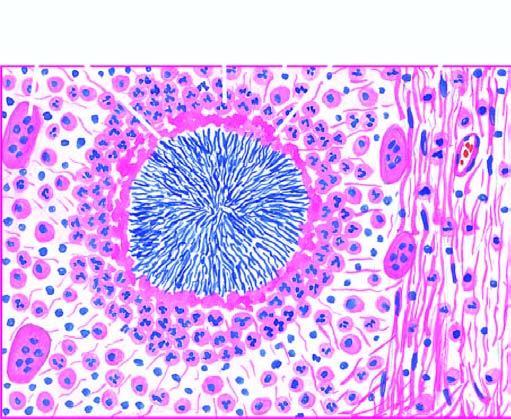what shows hyaline filaments highlighted by masson 's trichrome stain right photomicrograph?
Answer the question using a single word or phrase. The margin of the colony 